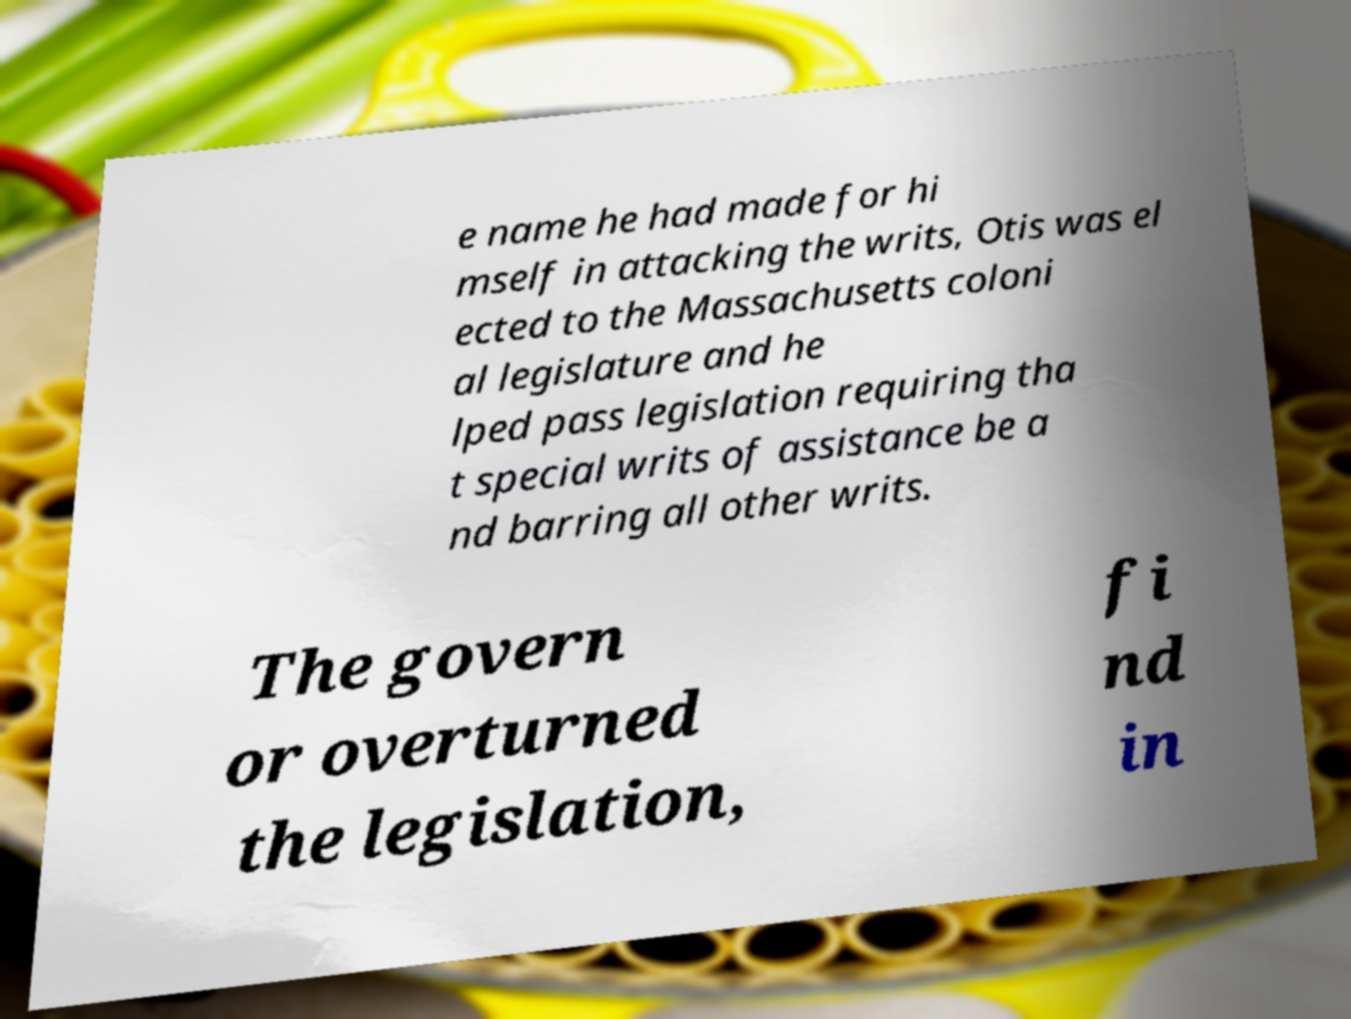Can you read and provide the text displayed in the image?This photo seems to have some interesting text. Can you extract and type it out for me? e name he had made for hi mself in attacking the writs, Otis was el ected to the Massachusetts coloni al legislature and he lped pass legislation requiring tha t special writs of assistance be a nd barring all other writs. The govern or overturned the legislation, fi nd in 